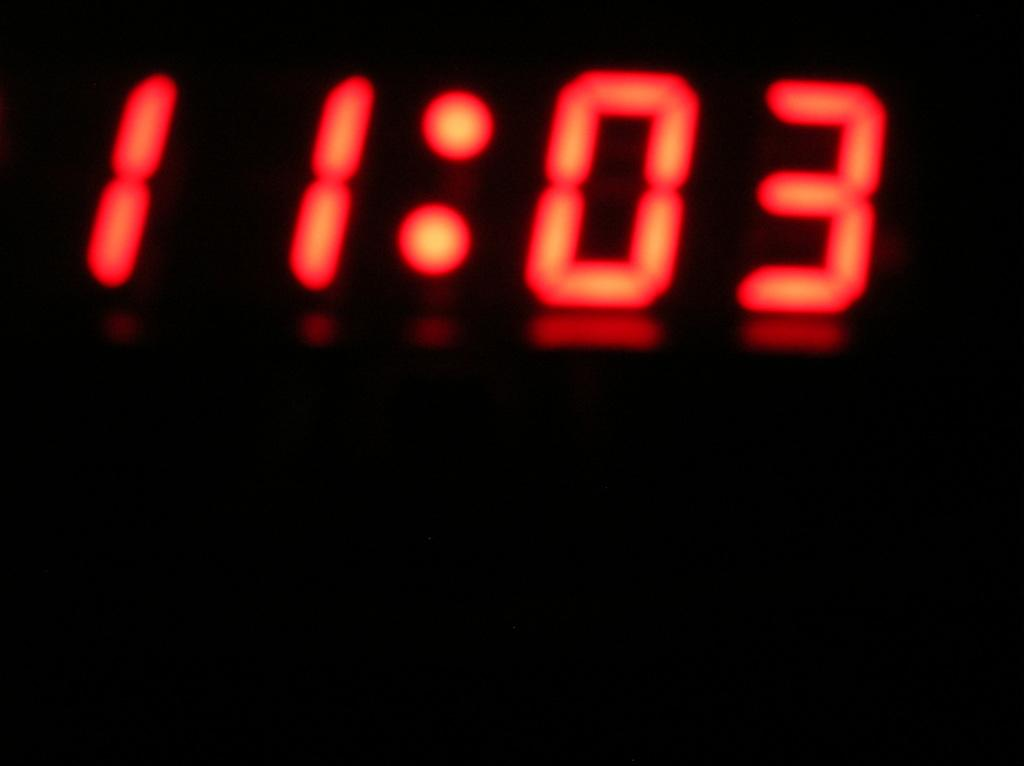Provide a one-sentence caption for the provided image. red and black clock with eleven o three on it. 